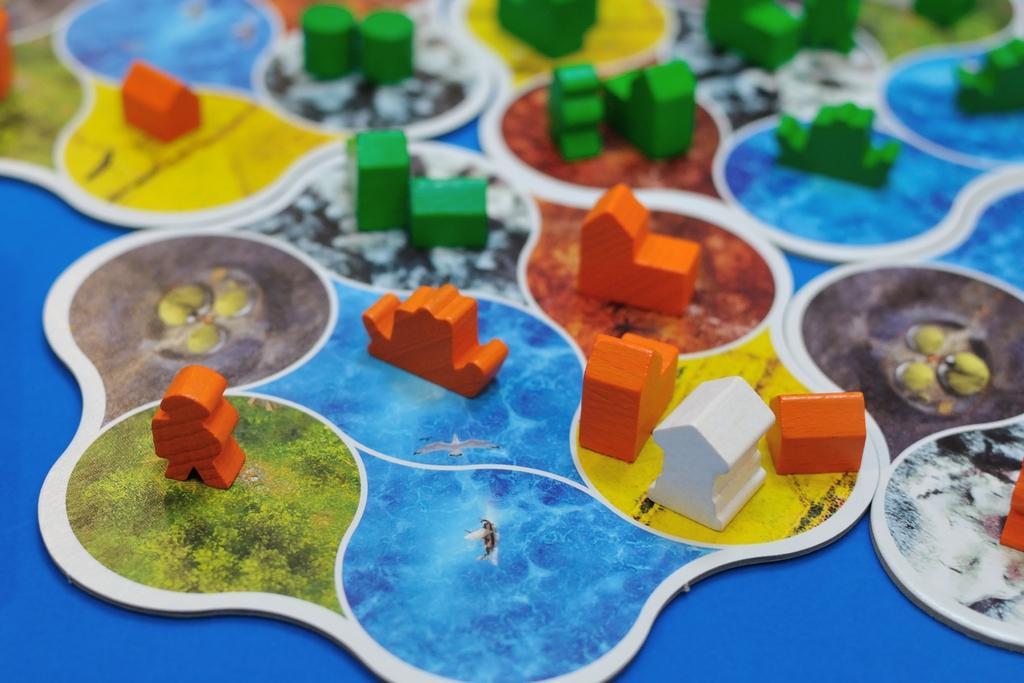Can you describe this image briefly? In this image there are small wooden blocks on the cardboard. On the cardboard there is some design. There are green colour,orange colour and white colour wooden blocks. 